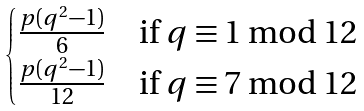<formula> <loc_0><loc_0><loc_500><loc_500>\begin{cases} \frac { p ( q ^ { 2 } - 1 ) } { 6 } & \text {if } q \equiv 1 \bmod { 1 2 } \\ \frac { p ( q ^ { 2 } - 1 ) } { 1 2 } & \text {if } q \equiv 7 \bmod { 1 2 } \end{cases}</formula> 